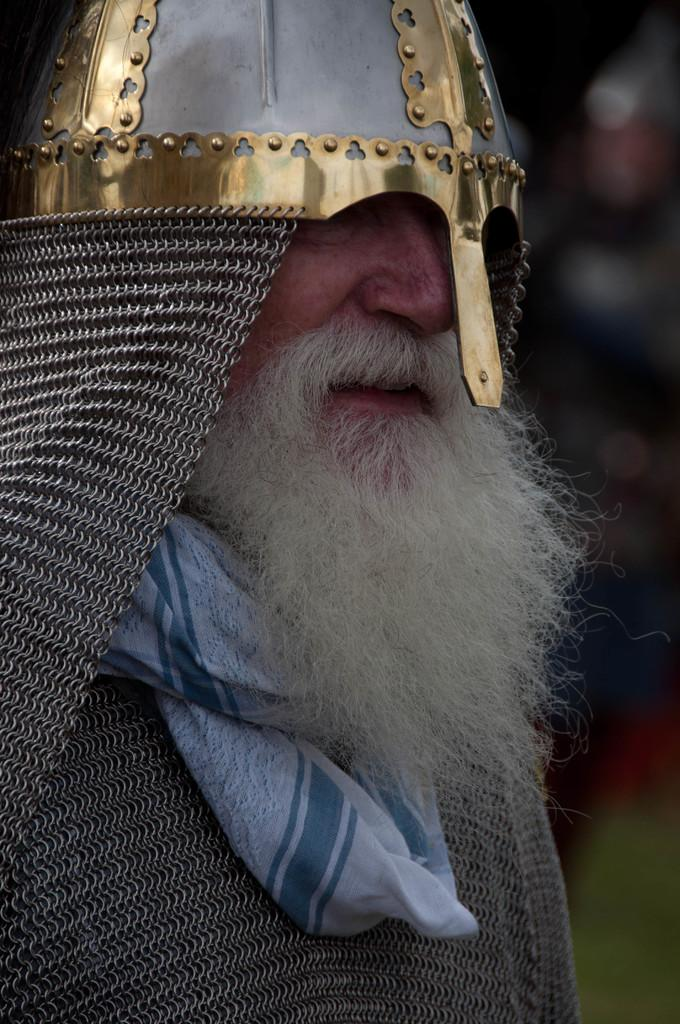What is the main subject of the image? There is a man standing in the image. What is the man wearing on his head? The man is wearing a helmet on his head. What type of clothing accessory is around the man's neck? There is a scarf around the man's neck. Can you describe the background of the image? The background of the image is blurry. What type of screw is being used to cover the man's head in the image? There is no screw present in the image; the man is wearing a helmet on his head. 